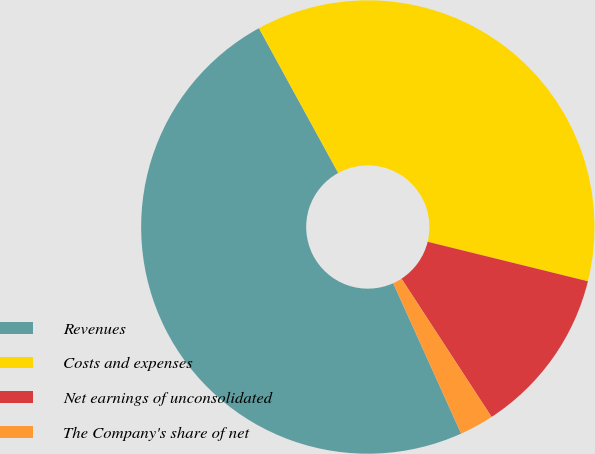<chart> <loc_0><loc_0><loc_500><loc_500><pie_chart><fcel>Revenues<fcel>Costs and expenses<fcel>Net earnings of unconsolidated<fcel>The Company's share of net<nl><fcel>48.78%<fcel>36.82%<fcel>11.96%<fcel>2.44%<nl></chart> 